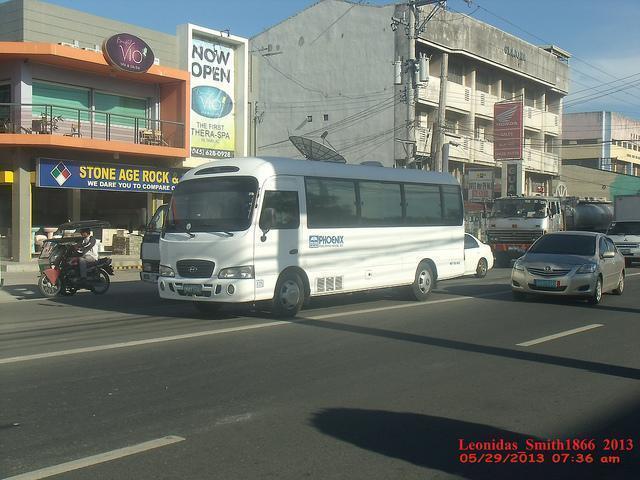What type of vehicle is sold in the building to the rear of the bus?
Indicate the correct choice and explain in the format: 'Answer: answer
Rationale: rationale.'
Options: Cars, motorcycles, tractors, trucks. Answer: motorcycles.
Rationale: There are bikes by the bus. 